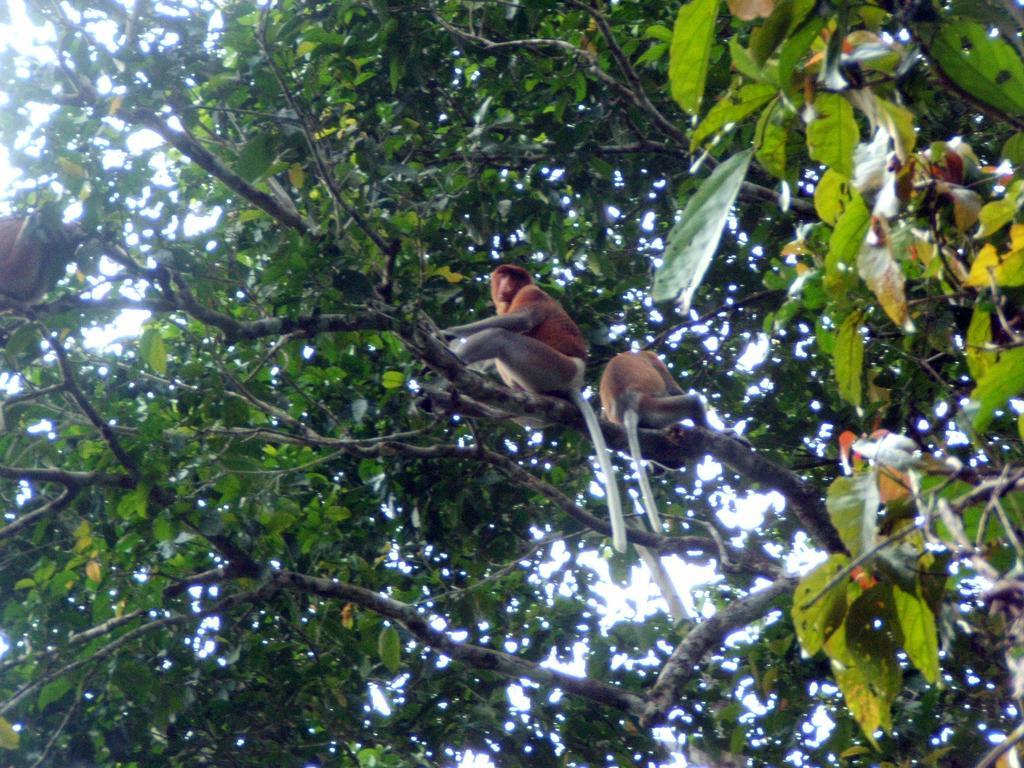Can you describe this image briefly? This is completely an outdoor picture. At the top of the picture partial part of the sky is visible through the tree. Here we can see two monkeys sitting on the branch of the tree. On the left side of the picture we can also see another monkey sitting. 